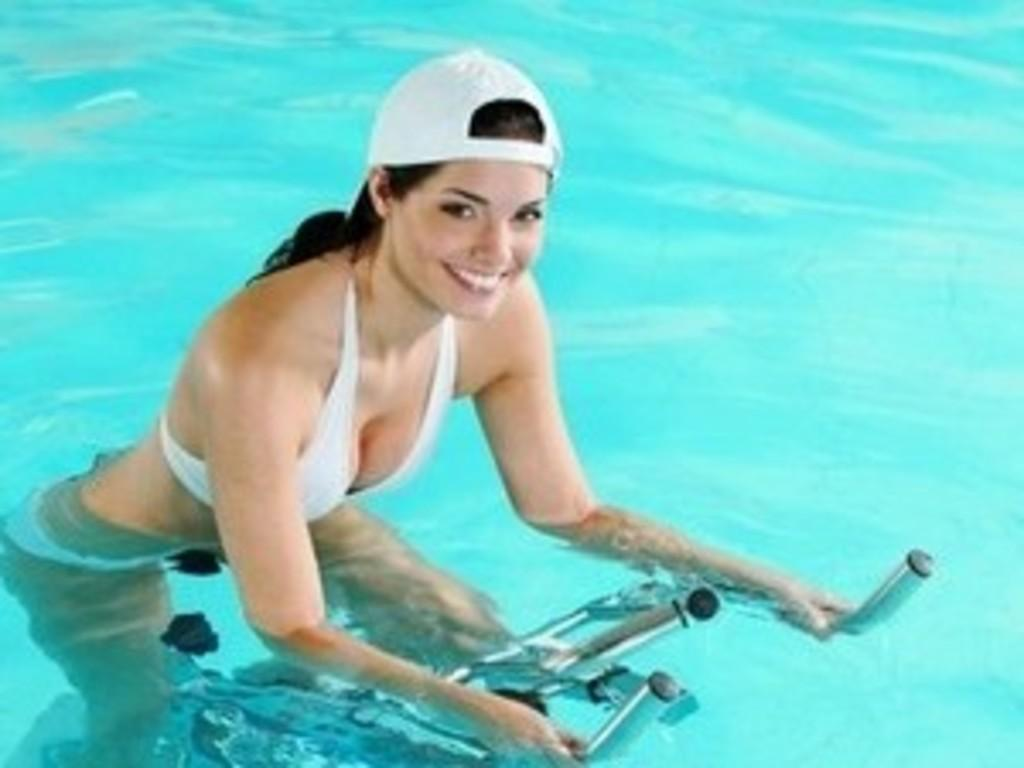Who is the main subject in the image? There is a woman in the image. What is the woman doing in the image? The woman is riding a bicycle. Where is the woman riding the bicycle? The woman is riding the bicycle on the water. What can be seen in the background of the image? There is water visible in the background of the image. What type of square can be seen in the image? There is no square present in the image. What kind of feast is being held in the image? There is no feast depicted in the image; it features a woman riding a bicycle on the water. 